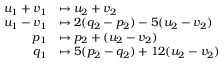Convert formula to latex. <formula><loc_0><loc_0><loc_500><loc_500>\begin{array} { r l } { u _ { 1 } + v _ { 1 } } & { \mapsto u _ { 2 } + v _ { 2 } } \\ { u _ { 1 } - v _ { 1 } } & { \mapsto 2 ( q _ { 2 } - p _ { 2 } ) - 5 ( u _ { 2 } - v _ { 2 } ) } \\ { p _ { 1 } } & { \mapsto p _ { 2 } + ( u _ { 2 } - v _ { 2 } ) } \\ { q _ { 1 } } & { \mapsto 5 ( p _ { 2 } - q _ { 2 } ) + 1 2 ( u _ { 2 } - v _ { 2 } ) } \end{array}</formula> 